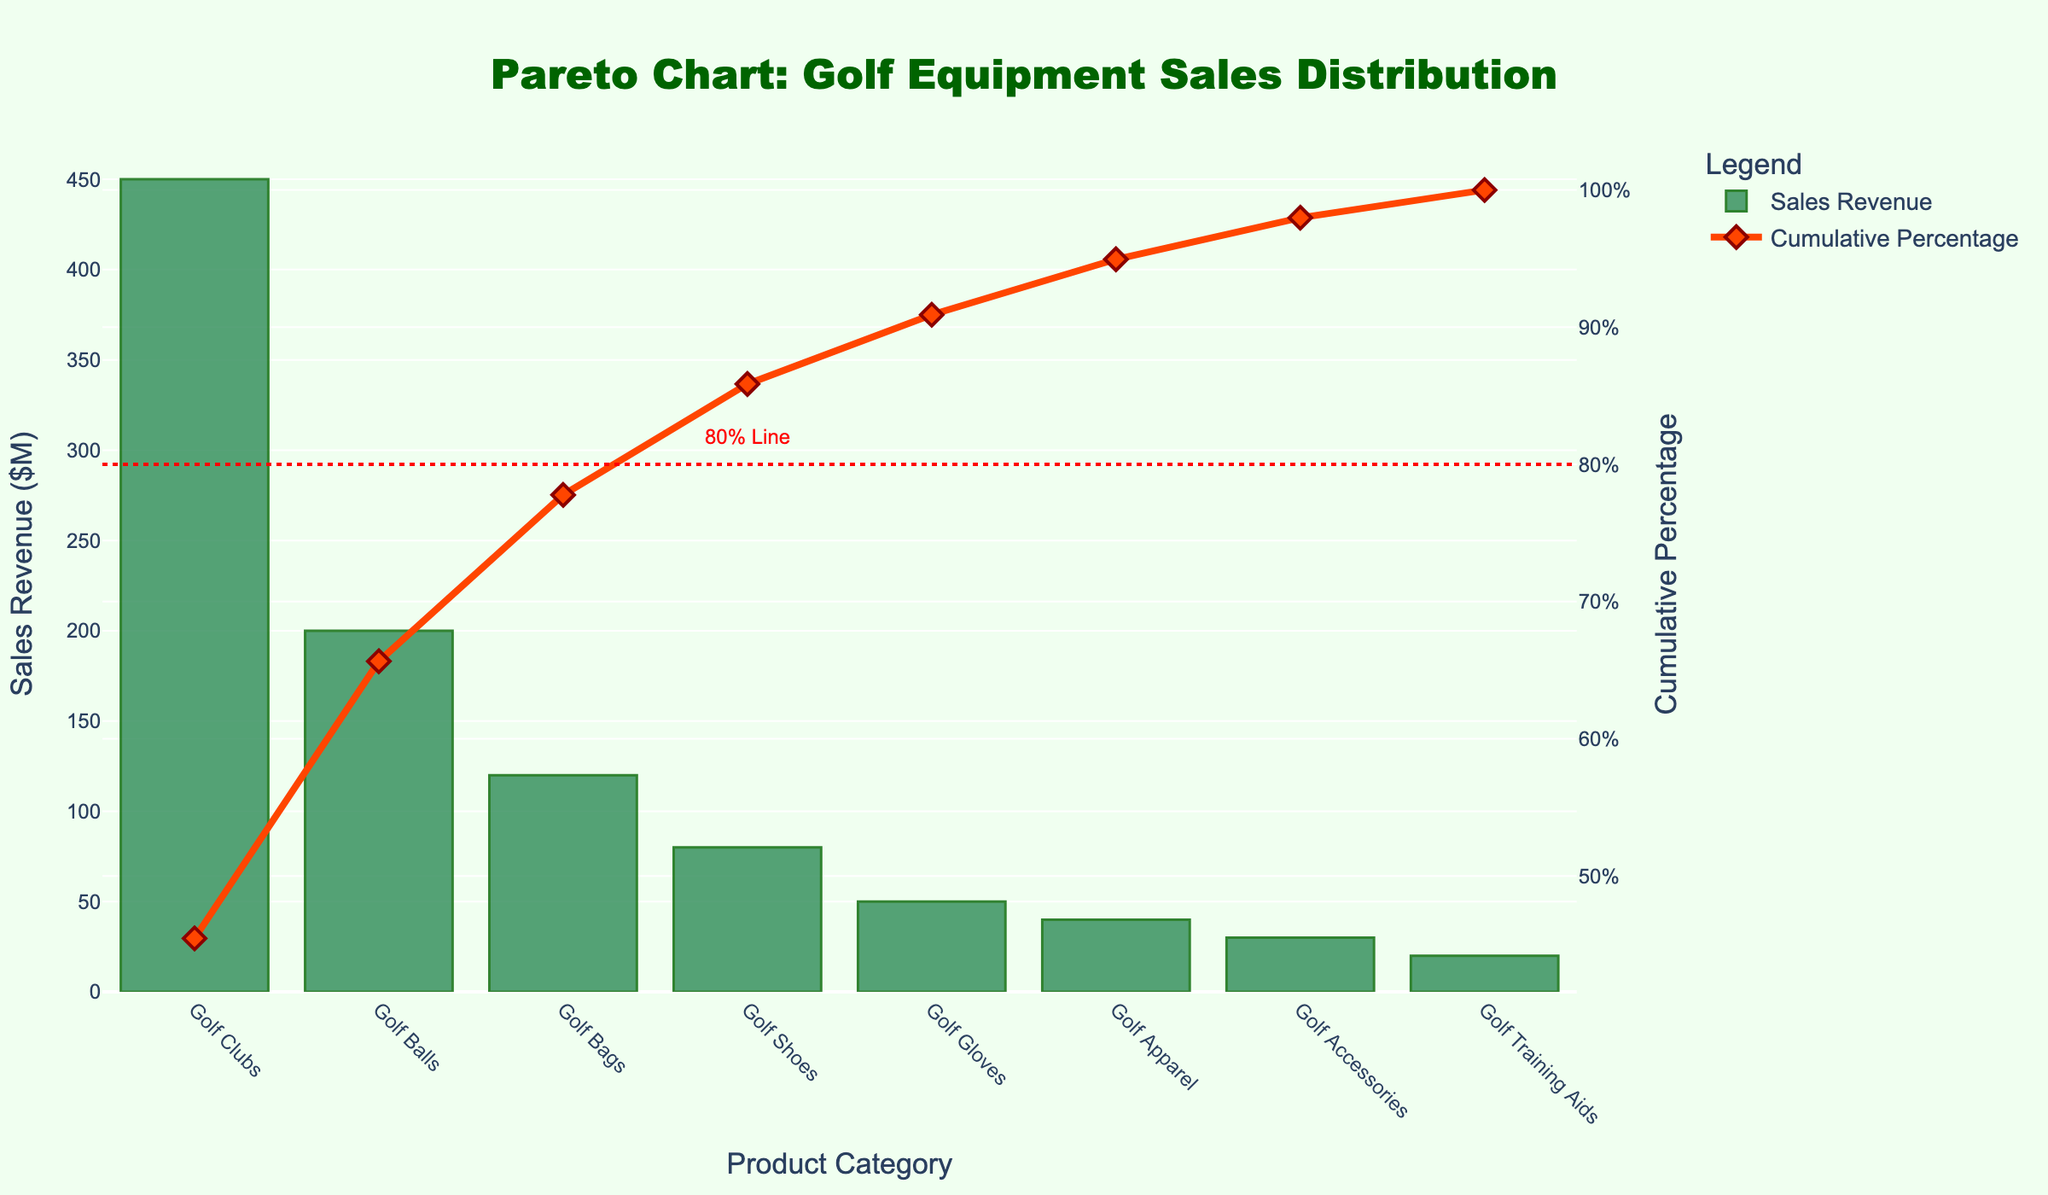what is the title of the chart? The title is typically found at the top of the chart and it provides an overview of the data being visualized.
Answer: Pareto Chart: Golf Equipment Sales Distribution which product category has the highest sales revenue? The product category with the tallest bar represents the highest sales revenue.
Answer: Golf Clubs what percentage of the total sales does the top two categories represent? Add the sales revenues of the top two categories and divide by the total sales revenue. Multiply by 100 to get the percentage.
Answer: 65% what is the sales revenue of Golf Bags? Look for the bar labeled "Golf Bags" to find the corresponding sales revenue.
Answer: $120M which product categories contribute to the cumulative percentage reaching 80%? Trace the cumulative percentage line until it reaches the 80% mark and note the contributing categories.
Answer: Golf Clubs, Golf Balls, Golf Bags, and Golf Shoes how many product categories achieve more than 50% cumulative percentage? Count the number of categories contributing to the cumulative percentage before it exceeds 50%.
Answer: Three which product category represents the smallest portion of sales revenue? Identify the bar representing the smallest value.
Answer: Golf Training Aids what is the cumulative percentage for Golf Gloves? Find the cumulative percentage value corresponding to the category "Golf Gloves" on the line graph.
Answer: 85% compare the sales revenue of Golf Shoes and Golf Apparel. Look at the height of the bars for "Golf Shoes" and "Golf Apparel" and read their values.
Answer: Golf Shoes: $80M, Golf Apparel: $40M what color represents the cumulative percentage line in the chart? Observe the color of the line graph representing the cumulative percentage on the chart.
Answer: Orange (with diamond markers) 